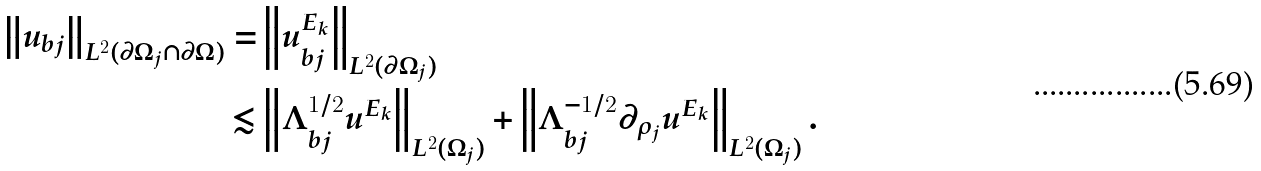<formula> <loc_0><loc_0><loc_500><loc_500>\left \| u _ { b j } \right \| _ { L ^ { 2 } ( \partial \Omega _ { j } \cap \partial \Omega ) } = & \left \| u _ { b j } ^ { E _ { k } } \right \| _ { L ^ { 2 } ( \partial \Omega _ { j } ) } \\ \lesssim & \left \| \Lambda _ { b j } ^ { 1 / 2 } u ^ { E _ { k } } \right \| _ { L ^ { 2 } ( \Omega _ { j } ) } + \left \| \Lambda _ { b j } ^ { - 1 / 2 } \partial _ { \rho _ { j } } u ^ { E _ { k } } \right \| _ { L ^ { 2 } ( \Omega _ { j } ) } .</formula> 